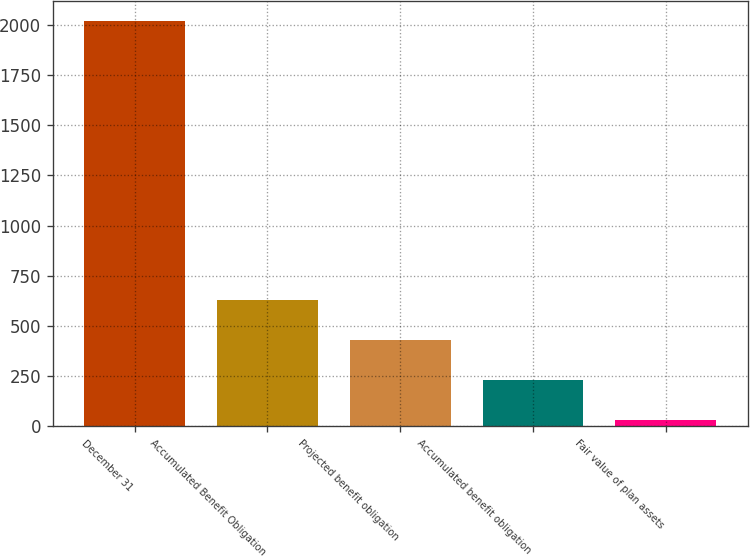Convert chart to OTSL. <chart><loc_0><loc_0><loc_500><loc_500><bar_chart><fcel>December 31<fcel>Accumulated Benefit Obligation<fcel>Projected benefit obligation<fcel>Accumulated benefit obligation<fcel>Fair value of plan assets<nl><fcel>2017<fcel>628.2<fcel>429.8<fcel>231.4<fcel>33<nl></chart> 